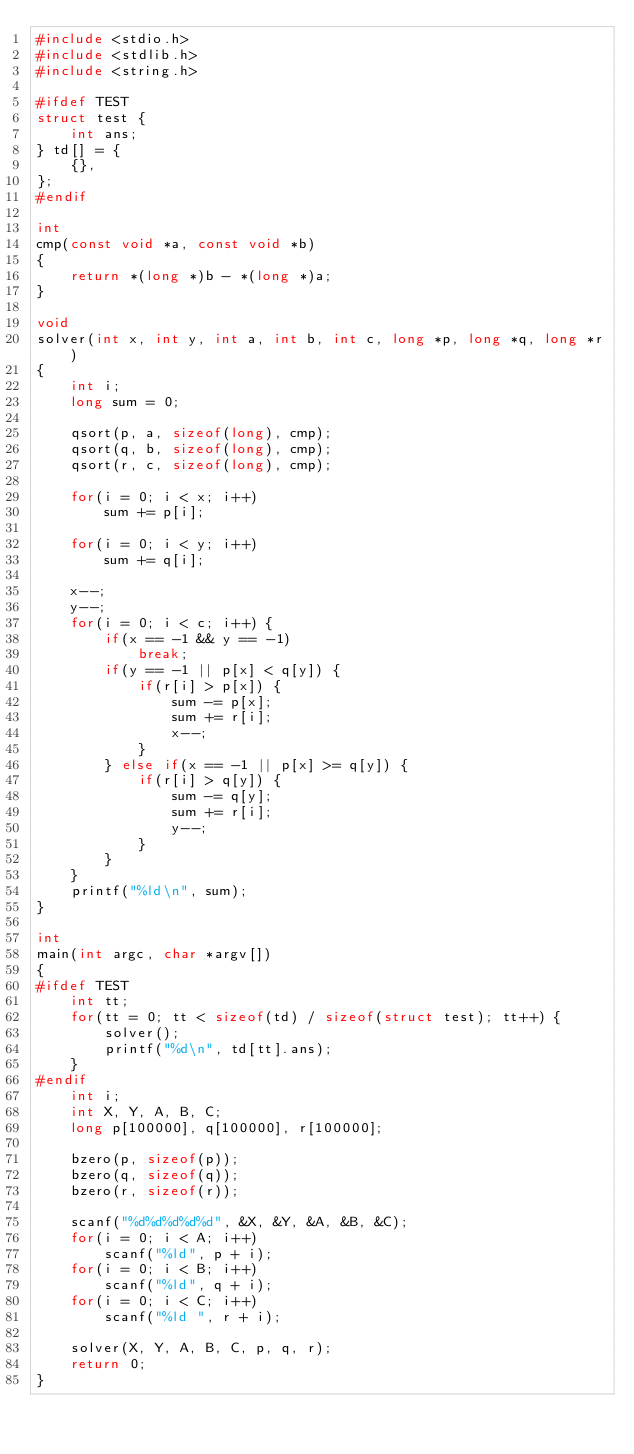<code> <loc_0><loc_0><loc_500><loc_500><_C_>#include <stdio.h>
#include <stdlib.h>
#include <string.h>

#ifdef TEST
struct test {
    int ans;
} td[] = {
    {},
};
#endif

int
cmp(const void *a, const void *b)
{
    return *(long *)b - *(long *)a;
}

void
solver(int x, int y, int a, int b, int c, long *p, long *q, long *r)
{
    int i;
    long sum = 0;

    qsort(p, a, sizeof(long), cmp);
    qsort(q, b, sizeof(long), cmp);
    qsort(r, c, sizeof(long), cmp);

    for(i = 0; i < x; i++)
        sum += p[i];

    for(i = 0; i < y; i++)
        sum += q[i];

    x--;
    y--;
    for(i = 0; i < c; i++) {
        if(x == -1 && y == -1)
            break;
        if(y == -1 || p[x] < q[y]) {
            if(r[i] > p[x]) {
                sum -= p[x];
                sum += r[i];
                x--;
            }
        } else if(x == -1 || p[x] >= q[y]) {
            if(r[i] > q[y]) {
                sum -= q[y];
                sum += r[i];
                y--;
            }
        }
    }
    printf("%ld\n", sum);
}

int
main(int argc, char *argv[])
{
#ifdef TEST
    int tt;
    for(tt = 0; tt < sizeof(td) / sizeof(struct test); tt++) {
        solver();
        printf("%d\n", td[tt].ans);
    }
#endif
    int i;
    int X, Y, A, B, C;
    long p[100000], q[100000], r[100000];

    bzero(p, sizeof(p));
    bzero(q, sizeof(q));
    bzero(r, sizeof(r));

    scanf("%d%d%d%d%d", &X, &Y, &A, &B, &C);
    for(i = 0; i < A; i++)
        scanf("%ld", p + i);
    for(i = 0; i < B; i++)
        scanf("%ld", q + i);
    for(i = 0; i < C; i++)
        scanf("%ld ", r + i);

    solver(X, Y, A, B, C, p, q, r);
    return 0;
}</code> 